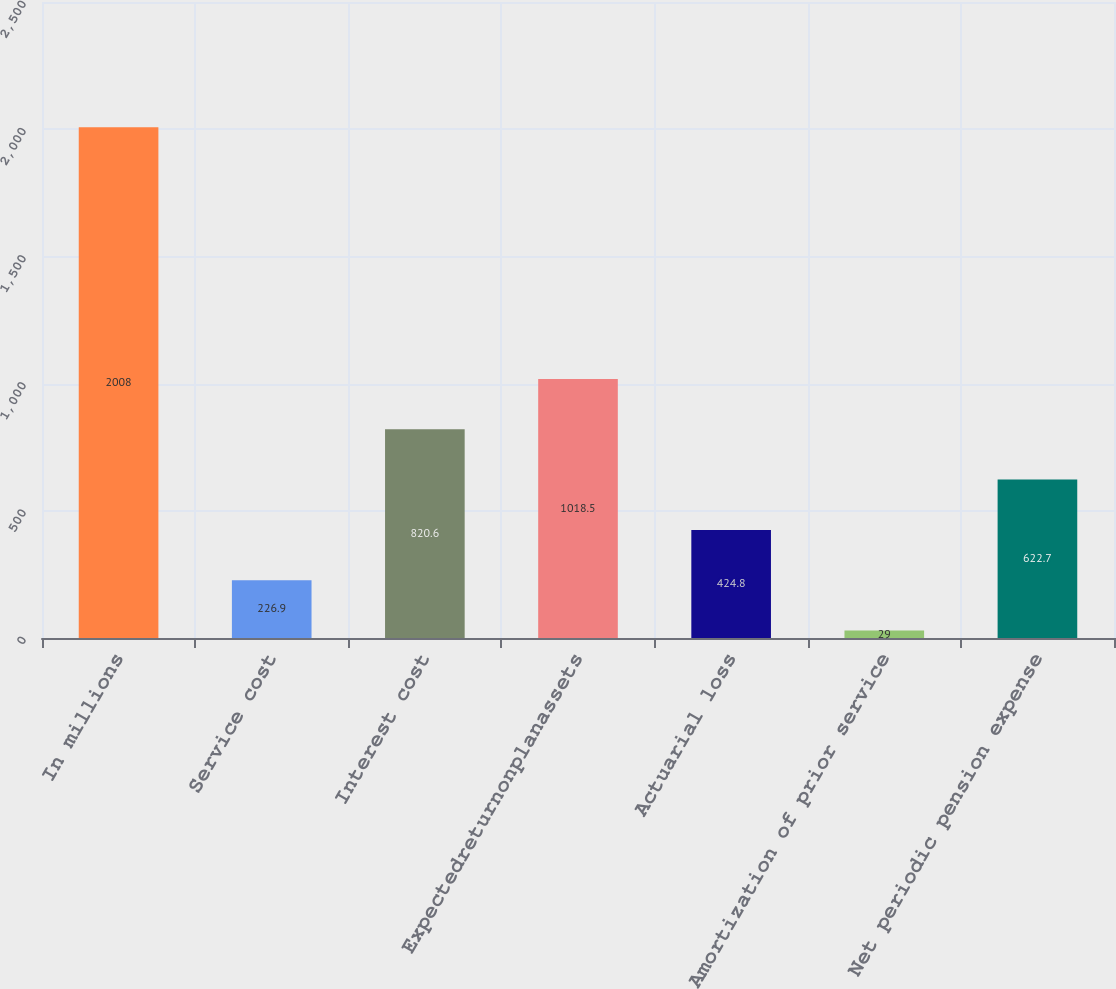Convert chart to OTSL. <chart><loc_0><loc_0><loc_500><loc_500><bar_chart><fcel>In millions<fcel>Service cost<fcel>Interest cost<fcel>Expectedreturnonplanassets<fcel>Actuarial loss<fcel>Amortization of prior service<fcel>Net periodic pension expense<nl><fcel>2008<fcel>226.9<fcel>820.6<fcel>1018.5<fcel>424.8<fcel>29<fcel>622.7<nl></chart> 